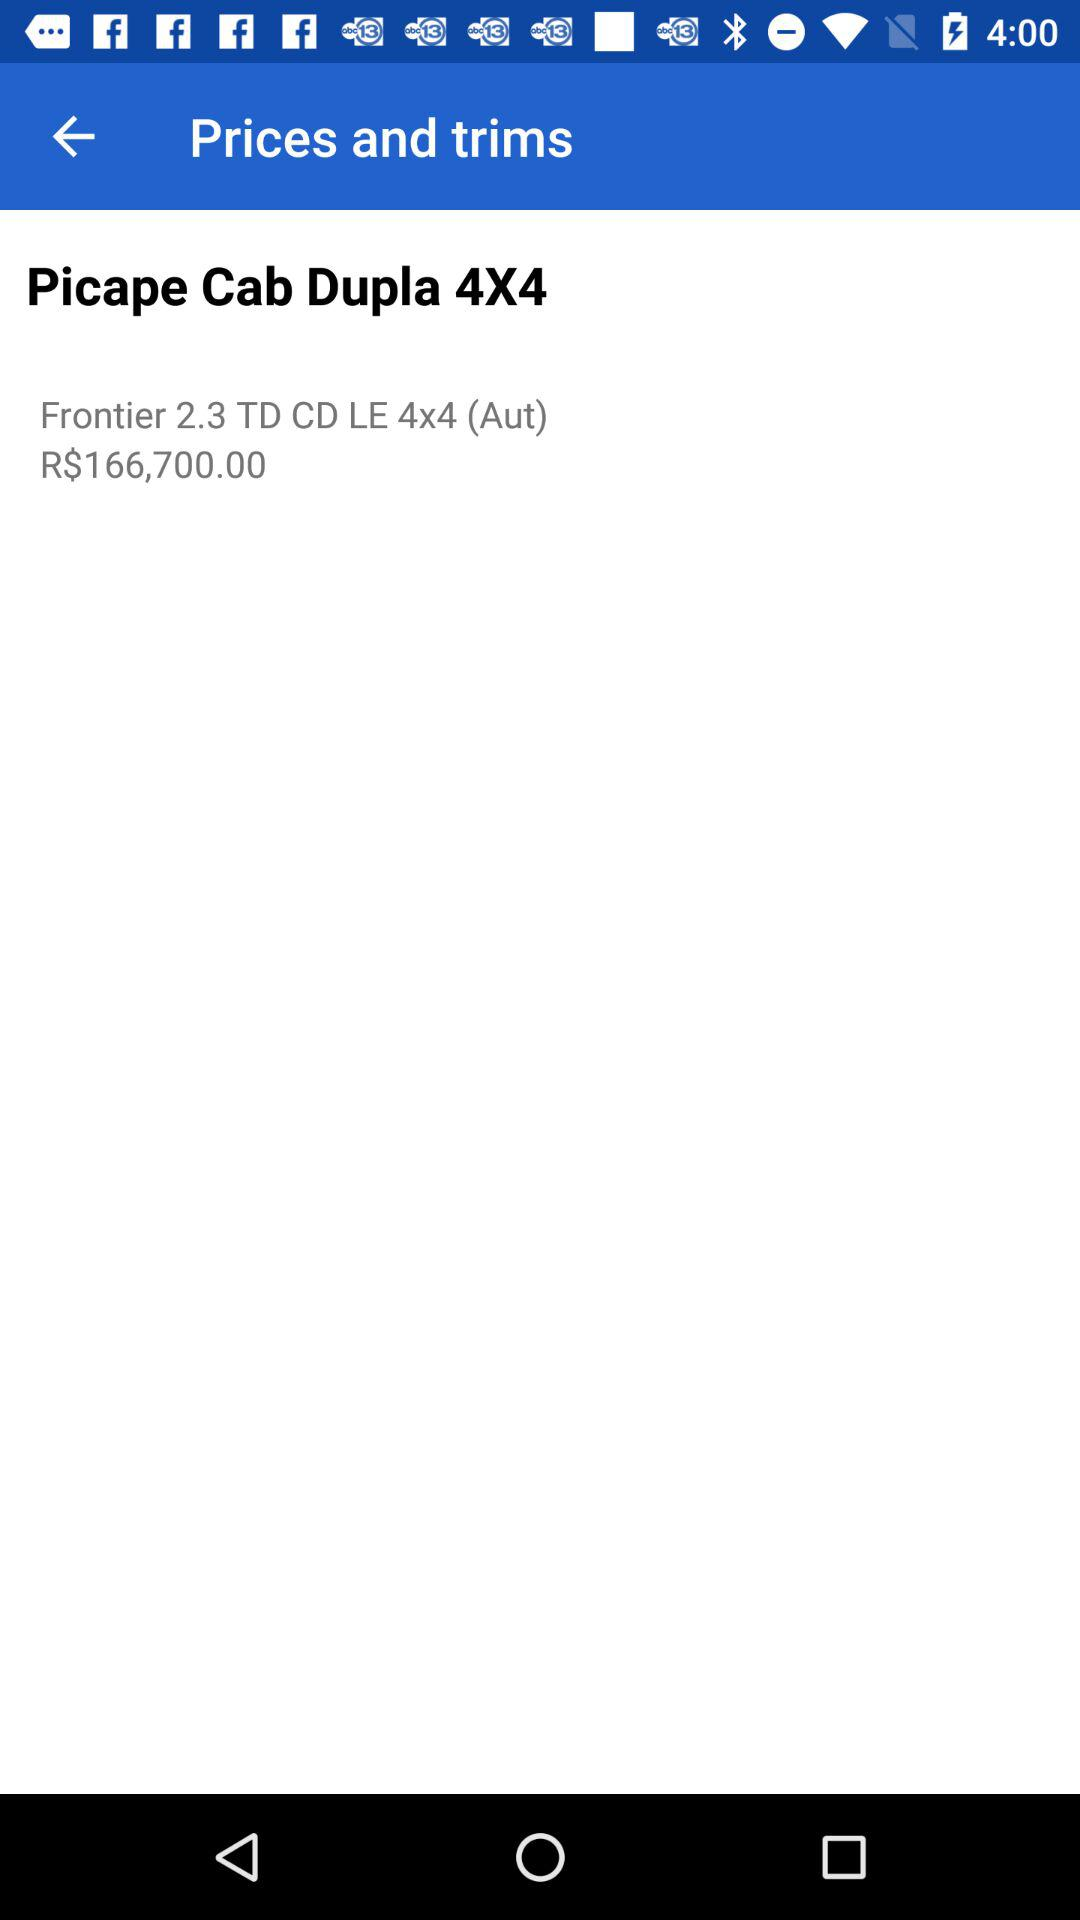How much more expensive is the Frontier 2.3 TD CD LE 4x4 (Aut) than the Picape Cab Dupla 4X4?
Answer the question using a single word or phrase. R$166,700.00 